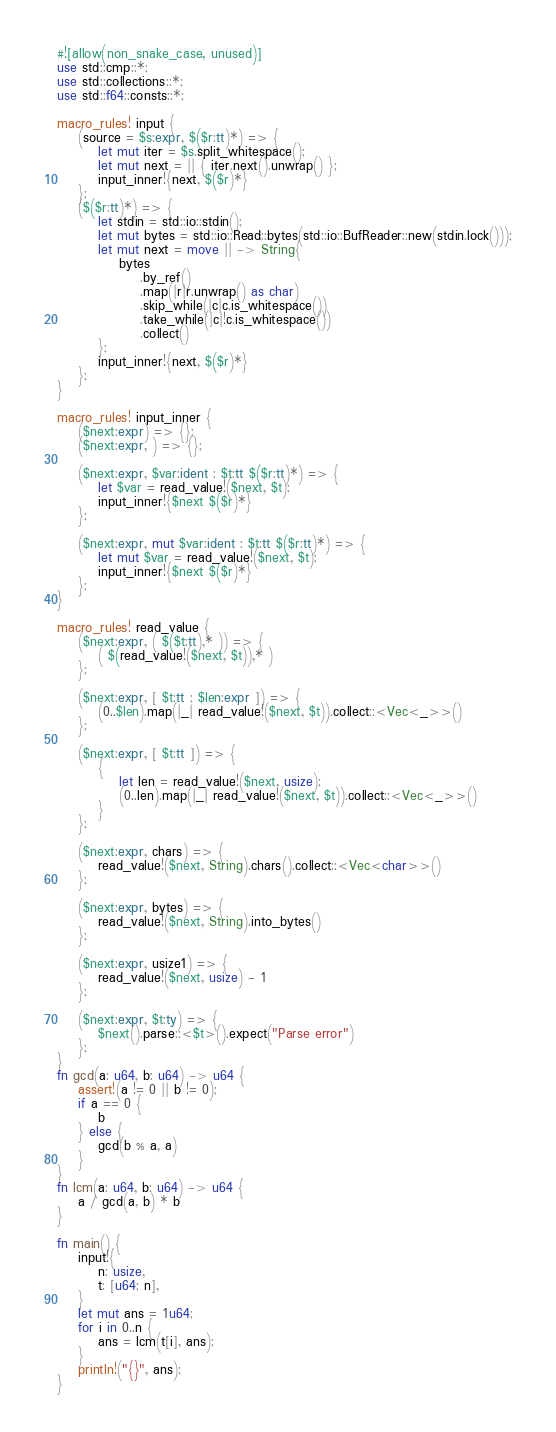Convert code to text. <code><loc_0><loc_0><loc_500><loc_500><_Rust_>#![allow(non_snake_case, unused)]
use std::cmp::*;
use std::collections::*;
use std::f64::consts::*;

macro_rules! input {
    (source = $s:expr, $($r:tt)*) => {
        let mut iter = $s.split_whitespace();
        let mut next = || { iter.next().unwrap() };
        input_inner!{next, $($r)*}
    };
    ($($r:tt)*) => {
        let stdin = std::io::stdin();
        let mut bytes = std::io::Read::bytes(std::io::BufReader::new(stdin.lock()));
        let mut next = move || -> String{
            bytes
                .by_ref()
                .map(|r|r.unwrap() as char)
                .skip_while(|c|c.is_whitespace())
                .take_while(|c|!c.is_whitespace())
                .collect()
        };
        input_inner!{next, $($r)*}
    };
}

macro_rules! input_inner {
    ($next:expr) => {};
    ($next:expr, ) => {};

    ($next:expr, $var:ident : $t:tt $($r:tt)*) => {
        let $var = read_value!($next, $t);
        input_inner!{$next $($r)*}
    };

    ($next:expr, mut $var:ident : $t:tt $($r:tt)*) => {
        let mut $var = read_value!($next, $t);
        input_inner!{$next $($r)*}
    };
}

macro_rules! read_value {
    ($next:expr, ( $($t:tt),* )) => {
        ( $(read_value!($next, $t)),* )
    };

    ($next:expr, [ $t:tt ; $len:expr ]) => {
        (0..$len).map(|_| read_value!($next, $t)).collect::<Vec<_>>()
    };

    ($next:expr, [ $t:tt ]) => {
        {
            let len = read_value!($next, usize);
            (0..len).map(|_| read_value!($next, $t)).collect::<Vec<_>>()
        }
    };

    ($next:expr, chars) => {
        read_value!($next, String).chars().collect::<Vec<char>>()
    };

    ($next:expr, bytes) => {
        read_value!($next, String).into_bytes()
    };

    ($next:expr, usize1) => {
        read_value!($next, usize) - 1
    };

    ($next:expr, $t:ty) => {
        $next().parse::<$t>().expect("Parse error")
    };
}
fn gcd(a: u64, b: u64) -> u64 {
    assert!(a != 0 || b != 0);
    if a == 0 {
        b
    } else {
        gcd(b % a, a)
    }
}
fn lcm(a: u64, b: u64) -> u64 {
    a / gcd(a, b) * b
}

fn main() {
    input!{
        n: usize,
        t: [u64; n],
    }
    let mut ans = 1u64;
    for i in 0..n {
        ans = lcm(t[i], ans);
    }
    println!("{}", ans);
}
</code> 